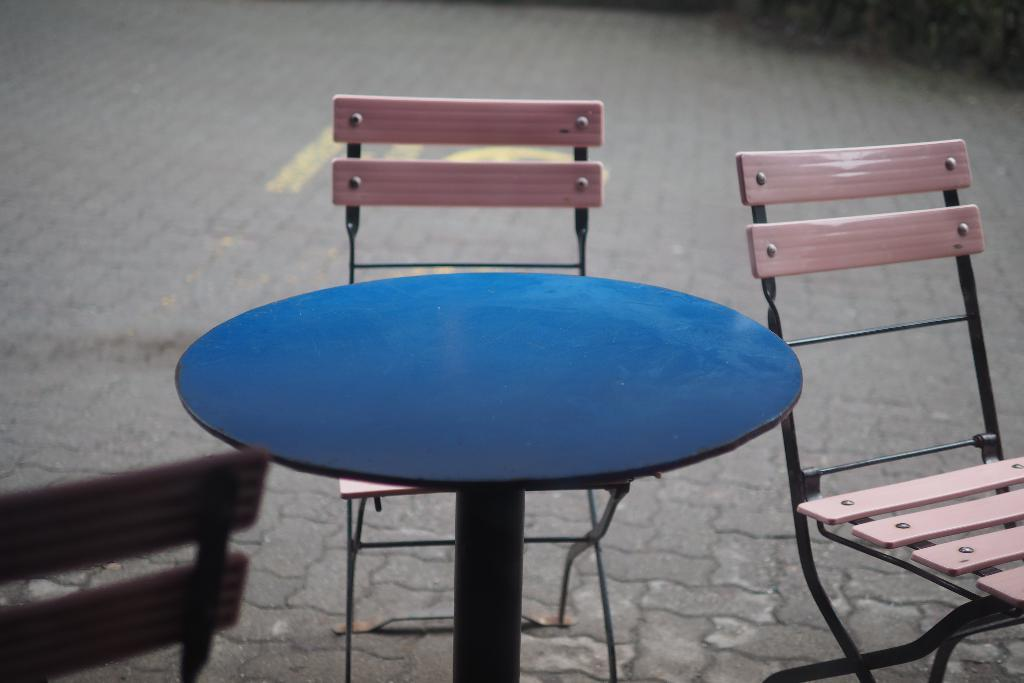What type of furniture is present in the image? There is a table in the image. What color is the table? The table is blue. Are there any chairs around the table? Yes, there are chairs around the table. What color are the chairs? The chairs are pink. What can be seen in the background of the image? The background of the image includes the floor. What type of bead is used to create the table's surface in the image? There is no mention of beads being used in the image; the table's surface is not described in detail. 